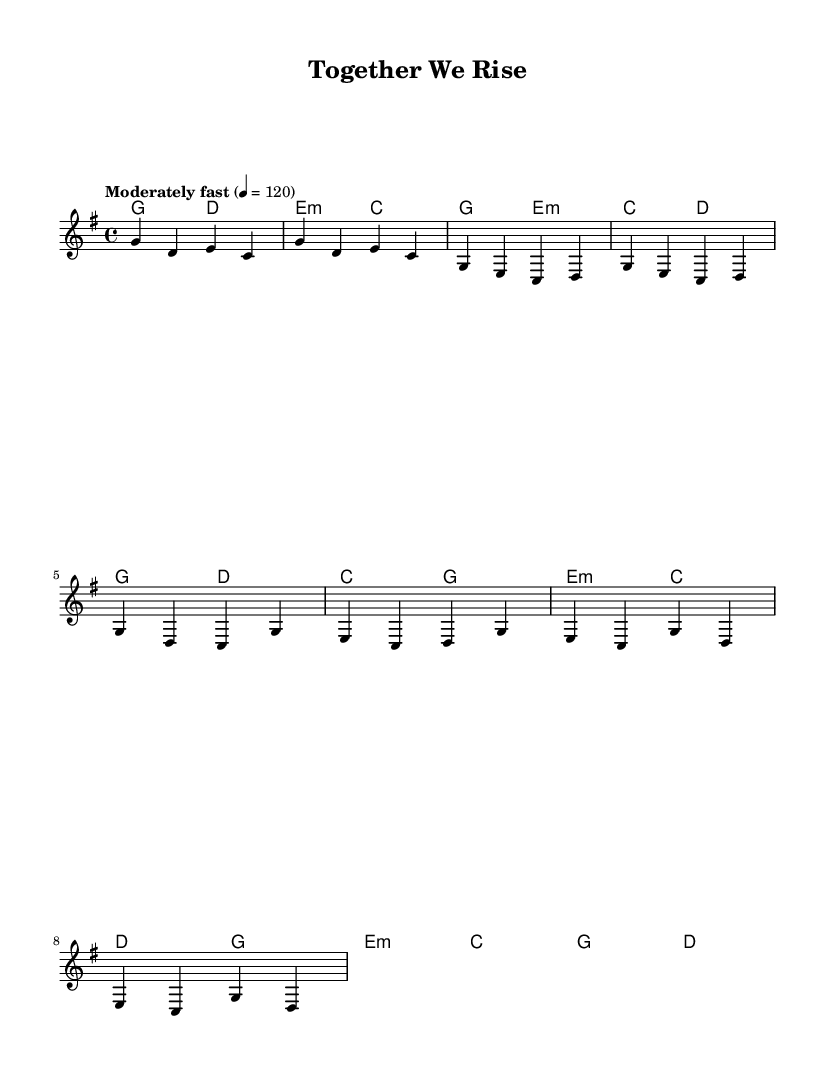What is the key signature of this music? The key signature is G major, which has one sharp (F#). We identify the key signature by looking at the beginning of the staff where the sharps or flats are indicated.
Answer: G major What is the time signature of this music? The time signature is 4/4, which is indicated at the beginning of the score. It shows that there are four beats in each measure and a quarter note gets one beat.
Answer: 4/4 What is the tempo marking for this piece? The tempo marking is "Moderately fast" at a quarter note equals 120 beats per minute. This is stated at the beginning of the score and indicates the speed at which the piece should be played.
Answer: Moderately fast How many measures are in the chorus section? The chorus section consists of four measures, as can be counted directly from the melody notation provided. Each measure is represented by a clear set of notes separated by vertical lines.
Answer: 4 What is the main theme of the lyrics? The main theme of the lyrics is teamwork and unity, reflected in phrases like "Together we rise" and "Our strength is in numbers." This theme is evident in both the verses and chorus, highlighting collaboration.
Answer: Teamwork and unity Which section has lyrics about strength in numbers? The bridge section contains lyrics specifically mentioning "Our strength is in numbers," indicating that this is where the message of collective power is emphasized. We find this information by reviewing the lyrics associated with each section of the music.
Answer: Bridge How many chords are used in the verse? The verse uses three different chords: G major, E minor, and D major. By analyzing the harmony section and looking at the chord changes during the verse, we can identify the distinct chords employed.
Answer: 3 